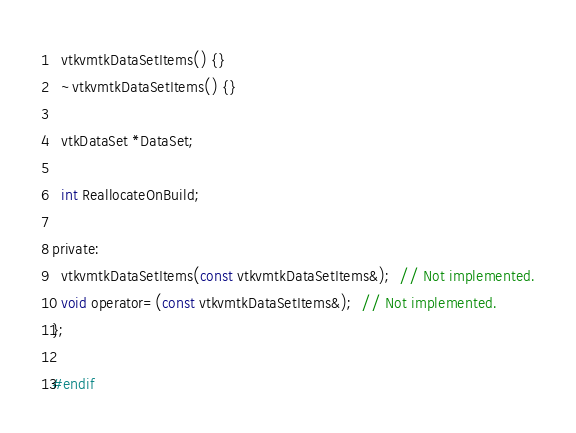<code> <loc_0><loc_0><loc_500><loc_500><_C_>  vtkvmtkDataSetItems() {}
  ~vtkvmtkDataSetItems() {}

  vtkDataSet *DataSet;

  int ReallocateOnBuild;

private:
  vtkvmtkDataSetItems(const vtkvmtkDataSetItems&);  // Not implemented.
  void operator=(const vtkvmtkDataSetItems&);  // Not implemented.
};

#endif

</code> 